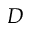<formula> <loc_0><loc_0><loc_500><loc_500>D</formula> 